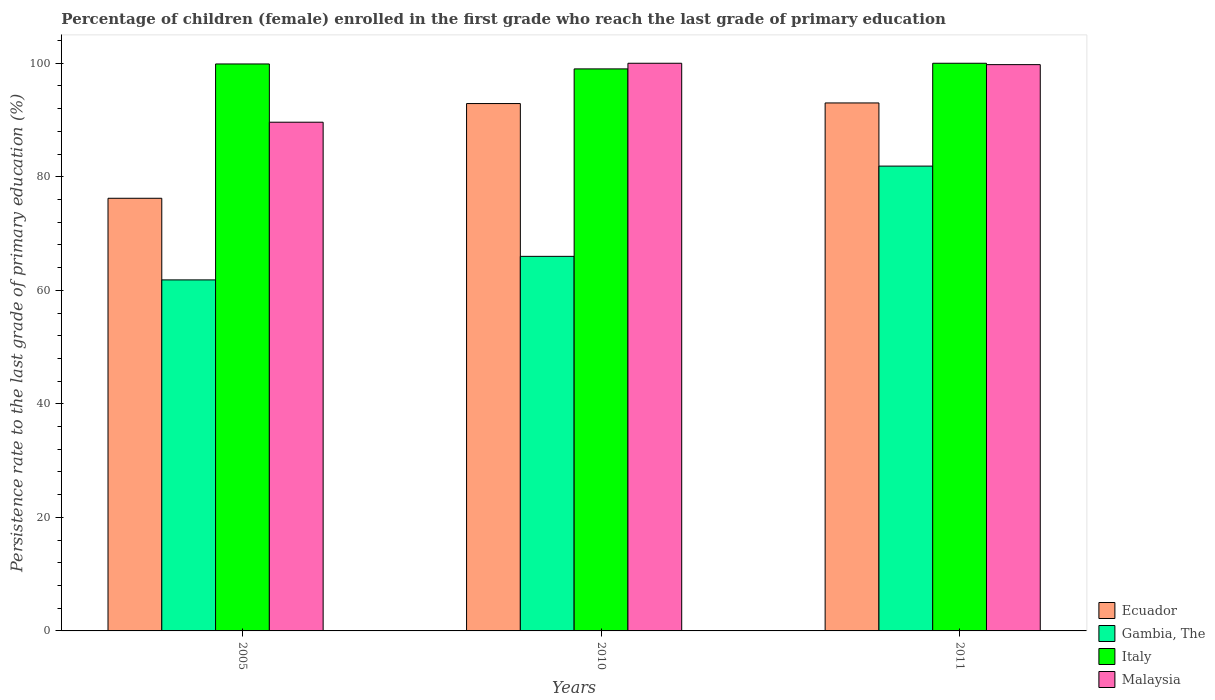How many different coloured bars are there?
Ensure brevity in your answer.  4. How many groups of bars are there?
Provide a succinct answer. 3. Are the number of bars per tick equal to the number of legend labels?
Make the answer very short. Yes. How many bars are there on the 1st tick from the left?
Keep it short and to the point. 4. How many bars are there on the 3rd tick from the right?
Your answer should be compact. 4. In how many cases, is the number of bars for a given year not equal to the number of legend labels?
Offer a terse response. 0. What is the persistence rate of children in Ecuador in 2011?
Ensure brevity in your answer.  93.01. Across all years, what is the maximum persistence rate of children in Ecuador?
Provide a succinct answer. 93.01. Across all years, what is the minimum persistence rate of children in Malaysia?
Keep it short and to the point. 89.61. In which year was the persistence rate of children in Gambia, The minimum?
Offer a terse response. 2005. What is the total persistence rate of children in Ecuador in the graph?
Provide a short and direct response. 262.13. What is the difference between the persistence rate of children in Malaysia in 2005 and that in 2011?
Ensure brevity in your answer.  -10.14. What is the difference between the persistence rate of children in Malaysia in 2011 and the persistence rate of children in Italy in 2005?
Ensure brevity in your answer.  -0.12. What is the average persistence rate of children in Malaysia per year?
Offer a terse response. 96.46. In the year 2005, what is the difference between the persistence rate of children in Ecuador and persistence rate of children in Italy?
Ensure brevity in your answer.  -23.66. In how many years, is the persistence rate of children in Malaysia greater than 36 %?
Provide a succinct answer. 3. What is the ratio of the persistence rate of children in Ecuador in 2010 to that in 2011?
Provide a succinct answer. 1. What is the difference between the highest and the second highest persistence rate of children in Italy?
Your response must be concise. 0.12. What is the difference between the highest and the lowest persistence rate of children in Ecuador?
Your answer should be compact. 16.79. Is the sum of the persistence rate of children in Malaysia in 2005 and 2011 greater than the maximum persistence rate of children in Italy across all years?
Your answer should be very brief. Yes. Is it the case that in every year, the sum of the persistence rate of children in Gambia, The and persistence rate of children in Malaysia is greater than the sum of persistence rate of children in Italy and persistence rate of children in Ecuador?
Offer a terse response. No. What does the 1st bar from the left in 2011 represents?
Offer a terse response. Ecuador. What does the 1st bar from the right in 2005 represents?
Offer a very short reply. Malaysia. How many bars are there?
Keep it short and to the point. 12. Are all the bars in the graph horizontal?
Give a very brief answer. No. Are the values on the major ticks of Y-axis written in scientific E-notation?
Offer a terse response. No. Where does the legend appear in the graph?
Ensure brevity in your answer.  Bottom right. How are the legend labels stacked?
Your response must be concise. Vertical. What is the title of the graph?
Provide a short and direct response. Percentage of children (female) enrolled in the first grade who reach the last grade of primary education. What is the label or title of the Y-axis?
Provide a succinct answer. Persistence rate to the last grade of primary education (%). What is the Persistence rate to the last grade of primary education (%) of Ecuador in 2005?
Your answer should be very brief. 76.22. What is the Persistence rate to the last grade of primary education (%) in Gambia, The in 2005?
Give a very brief answer. 61.84. What is the Persistence rate to the last grade of primary education (%) of Italy in 2005?
Provide a succinct answer. 99.88. What is the Persistence rate to the last grade of primary education (%) in Malaysia in 2005?
Ensure brevity in your answer.  89.61. What is the Persistence rate to the last grade of primary education (%) of Ecuador in 2010?
Keep it short and to the point. 92.9. What is the Persistence rate to the last grade of primary education (%) of Gambia, The in 2010?
Ensure brevity in your answer.  65.99. What is the Persistence rate to the last grade of primary education (%) of Italy in 2010?
Keep it short and to the point. 99.01. What is the Persistence rate to the last grade of primary education (%) in Ecuador in 2011?
Provide a succinct answer. 93.01. What is the Persistence rate to the last grade of primary education (%) of Gambia, The in 2011?
Keep it short and to the point. 81.88. What is the Persistence rate to the last grade of primary education (%) of Malaysia in 2011?
Provide a succinct answer. 99.76. Across all years, what is the maximum Persistence rate to the last grade of primary education (%) in Ecuador?
Your answer should be compact. 93.01. Across all years, what is the maximum Persistence rate to the last grade of primary education (%) in Gambia, The?
Offer a terse response. 81.88. Across all years, what is the maximum Persistence rate to the last grade of primary education (%) in Italy?
Give a very brief answer. 100. Across all years, what is the maximum Persistence rate to the last grade of primary education (%) of Malaysia?
Provide a succinct answer. 100. Across all years, what is the minimum Persistence rate to the last grade of primary education (%) of Ecuador?
Give a very brief answer. 76.22. Across all years, what is the minimum Persistence rate to the last grade of primary education (%) in Gambia, The?
Your response must be concise. 61.84. Across all years, what is the minimum Persistence rate to the last grade of primary education (%) of Italy?
Your answer should be compact. 99.01. Across all years, what is the minimum Persistence rate to the last grade of primary education (%) of Malaysia?
Keep it short and to the point. 89.61. What is the total Persistence rate to the last grade of primary education (%) of Ecuador in the graph?
Keep it short and to the point. 262.13. What is the total Persistence rate to the last grade of primary education (%) in Gambia, The in the graph?
Keep it short and to the point. 209.71. What is the total Persistence rate to the last grade of primary education (%) of Italy in the graph?
Keep it short and to the point. 298.88. What is the total Persistence rate to the last grade of primary education (%) in Malaysia in the graph?
Offer a very short reply. 289.37. What is the difference between the Persistence rate to the last grade of primary education (%) of Ecuador in 2005 and that in 2010?
Your answer should be very brief. -16.69. What is the difference between the Persistence rate to the last grade of primary education (%) of Gambia, The in 2005 and that in 2010?
Your answer should be compact. -4.15. What is the difference between the Persistence rate to the last grade of primary education (%) in Italy in 2005 and that in 2010?
Your answer should be compact. 0.87. What is the difference between the Persistence rate to the last grade of primary education (%) in Malaysia in 2005 and that in 2010?
Your answer should be very brief. -10.39. What is the difference between the Persistence rate to the last grade of primary education (%) in Ecuador in 2005 and that in 2011?
Offer a very short reply. -16.79. What is the difference between the Persistence rate to the last grade of primary education (%) in Gambia, The in 2005 and that in 2011?
Offer a terse response. -20.04. What is the difference between the Persistence rate to the last grade of primary education (%) in Italy in 2005 and that in 2011?
Make the answer very short. -0.12. What is the difference between the Persistence rate to the last grade of primary education (%) in Malaysia in 2005 and that in 2011?
Ensure brevity in your answer.  -10.14. What is the difference between the Persistence rate to the last grade of primary education (%) in Ecuador in 2010 and that in 2011?
Ensure brevity in your answer.  -0.1. What is the difference between the Persistence rate to the last grade of primary education (%) in Gambia, The in 2010 and that in 2011?
Keep it short and to the point. -15.9. What is the difference between the Persistence rate to the last grade of primary education (%) of Italy in 2010 and that in 2011?
Your answer should be compact. -0.99. What is the difference between the Persistence rate to the last grade of primary education (%) in Malaysia in 2010 and that in 2011?
Offer a terse response. 0.24. What is the difference between the Persistence rate to the last grade of primary education (%) of Ecuador in 2005 and the Persistence rate to the last grade of primary education (%) of Gambia, The in 2010?
Provide a succinct answer. 10.23. What is the difference between the Persistence rate to the last grade of primary education (%) in Ecuador in 2005 and the Persistence rate to the last grade of primary education (%) in Italy in 2010?
Ensure brevity in your answer.  -22.79. What is the difference between the Persistence rate to the last grade of primary education (%) of Ecuador in 2005 and the Persistence rate to the last grade of primary education (%) of Malaysia in 2010?
Ensure brevity in your answer.  -23.78. What is the difference between the Persistence rate to the last grade of primary education (%) of Gambia, The in 2005 and the Persistence rate to the last grade of primary education (%) of Italy in 2010?
Offer a very short reply. -37.17. What is the difference between the Persistence rate to the last grade of primary education (%) in Gambia, The in 2005 and the Persistence rate to the last grade of primary education (%) in Malaysia in 2010?
Keep it short and to the point. -38.16. What is the difference between the Persistence rate to the last grade of primary education (%) of Italy in 2005 and the Persistence rate to the last grade of primary education (%) of Malaysia in 2010?
Make the answer very short. -0.12. What is the difference between the Persistence rate to the last grade of primary education (%) of Ecuador in 2005 and the Persistence rate to the last grade of primary education (%) of Gambia, The in 2011?
Ensure brevity in your answer.  -5.67. What is the difference between the Persistence rate to the last grade of primary education (%) of Ecuador in 2005 and the Persistence rate to the last grade of primary education (%) of Italy in 2011?
Provide a short and direct response. -23.78. What is the difference between the Persistence rate to the last grade of primary education (%) in Ecuador in 2005 and the Persistence rate to the last grade of primary education (%) in Malaysia in 2011?
Your answer should be compact. -23.54. What is the difference between the Persistence rate to the last grade of primary education (%) in Gambia, The in 2005 and the Persistence rate to the last grade of primary education (%) in Italy in 2011?
Offer a very short reply. -38.16. What is the difference between the Persistence rate to the last grade of primary education (%) in Gambia, The in 2005 and the Persistence rate to the last grade of primary education (%) in Malaysia in 2011?
Ensure brevity in your answer.  -37.92. What is the difference between the Persistence rate to the last grade of primary education (%) in Italy in 2005 and the Persistence rate to the last grade of primary education (%) in Malaysia in 2011?
Your response must be concise. 0.12. What is the difference between the Persistence rate to the last grade of primary education (%) in Ecuador in 2010 and the Persistence rate to the last grade of primary education (%) in Gambia, The in 2011?
Your response must be concise. 11.02. What is the difference between the Persistence rate to the last grade of primary education (%) in Ecuador in 2010 and the Persistence rate to the last grade of primary education (%) in Italy in 2011?
Give a very brief answer. -7.1. What is the difference between the Persistence rate to the last grade of primary education (%) of Ecuador in 2010 and the Persistence rate to the last grade of primary education (%) of Malaysia in 2011?
Give a very brief answer. -6.86. What is the difference between the Persistence rate to the last grade of primary education (%) of Gambia, The in 2010 and the Persistence rate to the last grade of primary education (%) of Italy in 2011?
Give a very brief answer. -34.01. What is the difference between the Persistence rate to the last grade of primary education (%) in Gambia, The in 2010 and the Persistence rate to the last grade of primary education (%) in Malaysia in 2011?
Give a very brief answer. -33.77. What is the difference between the Persistence rate to the last grade of primary education (%) in Italy in 2010 and the Persistence rate to the last grade of primary education (%) in Malaysia in 2011?
Make the answer very short. -0.75. What is the average Persistence rate to the last grade of primary education (%) of Ecuador per year?
Keep it short and to the point. 87.38. What is the average Persistence rate to the last grade of primary education (%) in Gambia, The per year?
Give a very brief answer. 69.9. What is the average Persistence rate to the last grade of primary education (%) of Italy per year?
Make the answer very short. 99.63. What is the average Persistence rate to the last grade of primary education (%) in Malaysia per year?
Your answer should be compact. 96.46. In the year 2005, what is the difference between the Persistence rate to the last grade of primary education (%) in Ecuador and Persistence rate to the last grade of primary education (%) in Gambia, The?
Provide a succinct answer. 14.38. In the year 2005, what is the difference between the Persistence rate to the last grade of primary education (%) in Ecuador and Persistence rate to the last grade of primary education (%) in Italy?
Offer a very short reply. -23.66. In the year 2005, what is the difference between the Persistence rate to the last grade of primary education (%) in Ecuador and Persistence rate to the last grade of primary education (%) in Malaysia?
Ensure brevity in your answer.  -13.4. In the year 2005, what is the difference between the Persistence rate to the last grade of primary education (%) in Gambia, The and Persistence rate to the last grade of primary education (%) in Italy?
Your answer should be very brief. -38.04. In the year 2005, what is the difference between the Persistence rate to the last grade of primary education (%) in Gambia, The and Persistence rate to the last grade of primary education (%) in Malaysia?
Your answer should be compact. -27.78. In the year 2005, what is the difference between the Persistence rate to the last grade of primary education (%) in Italy and Persistence rate to the last grade of primary education (%) in Malaysia?
Your response must be concise. 10.26. In the year 2010, what is the difference between the Persistence rate to the last grade of primary education (%) in Ecuador and Persistence rate to the last grade of primary education (%) in Gambia, The?
Your answer should be compact. 26.92. In the year 2010, what is the difference between the Persistence rate to the last grade of primary education (%) of Ecuador and Persistence rate to the last grade of primary education (%) of Italy?
Offer a terse response. -6.1. In the year 2010, what is the difference between the Persistence rate to the last grade of primary education (%) of Ecuador and Persistence rate to the last grade of primary education (%) of Malaysia?
Offer a terse response. -7.1. In the year 2010, what is the difference between the Persistence rate to the last grade of primary education (%) of Gambia, The and Persistence rate to the last grade of primary education (%) of Italy?
Offer a very short reply. -33.02. In the year 2010, what is the difference between the Persistence rate to the last grade of primary education (%) in Gambia, The and Persistence rate to the last grade of primary education (%) in Malaysia?
Ensure brevity in your answer.  -34.01. In the year 2010, what is the difference between the Persistence rate to the last grade of primary education (%) in Italy and Persistence rate to the last grade of primary education (%) in Malaysia?
Give a very brief answer. -0.99. In the year 2011, what is the difference between the Persistence rate to the last grade of primary education (%) of Ecuador and Persistence rate to the last grade of primary education (%) of Gambia, The?
Ensure brevity in your answer.  11.12. In the year 2011, what is the difference between the Persistence rate to the last grade of primary education (%) in Ecuador and Persistence rate to the last grade of primary education (%) in Italy?
Offer a terse response. -6.99. In the year 2011, what is the difference between the Persistence rate to the last grade of primary education (%) of Ecuador and Persistence rate to the last grade of primary education (%) of Malaysia?
Provide a short and direct response. -6.75. In the year 2011, what is the difference between the Persistence rate to the last grade of primary education (%) of Gambia, The and Persistence rate to the last grade of primary education (%) of Italy?
Provide a succinct answer. -18.12. In the year 2011, what is the difference between the Persistence rate to the last grade of primary education (%) in Gambia, The and Persistence rate to the last grade of primary education (%) in Malaysia?
Your response must be concise. -17.87. In the year 2011, what is the difference between the Persistence rate to the last grade of primary education (%) of Italy and Persistence rate to the last grade of primary education (%) of Malaysia?
Your answer should be compact. 0.24. What is the ratio of the Persistence rate to the last grade of primary education (%) in Ecuador in 2005 to that in 2010?
Your answer should be very brief. 0.82. What is the ratio of the Persistence rate to the last grade of primary education (%) of Gambia, The in 2005 to that in 2010?
Give a very brief answer. 0.94. What is the ratio of the Persistence rate to the last grade of primary education (%) in Italy in 2005 to that in 2010?
Keep it short and to the point. 1.01. What is the ratio of the Persistence rate to the last grade of primary education (%) in Malaysia in 2005 to that in 2010?
Keep it short and to the point. 0.9. What is the ratio of the Persistence rate to the last grade of primary education (%) in Ecuador in 2005 to that in 2011?
Your answer should be very brief. 0.82. What is the ratio of the Persistence rate to the last grade of primary education (%) of Gambia, The in 2005 to that in 2011?
Offer a very short reply. 0.76. What is the ratio of the Persistence rate to the last grade of primary education (%) in Malaysia in 2005 to that in 2011?
Offer a terse response. 0.9. What is the ratio of the Persistence rate to the last grade of primary education (%) of Gambia, The in 2010 to that in 2011?
Provide a short and direct response. 0.81. What is the ratio of the Persistence rate to the last grade of primary education (%) of Malaysia in 2010 to that in 2011?
Ensure brevity in your answer.  1. What is the difference between the highest and the second highest Persistence rate to the last grade of primary education (%) of Ecuador?
Provide a succinct answer. 0.1. What is the difference between the highest and the second highest Persistence rate to the last grade of primary education (%) in Gambia, The?
Provide a short and direct response. 15.9. What is the difference between the highest and the second highest Persistence rate to the last grade of primary education (%) of Italy?
Offer a very short reply. 0.12. What is the difference between the highest and the second highest Persistence rate to the last grade of primary education (%) in Malaysia?
Offer a terse response. 0.24. What is the difference between the highest and the lowest Persistence rate to the last grade of primary education (%) of Ecuador?
Keep it short and to the point. 16.79. What is the difference between the highest and the lowest Persistence rate to the last grade of primary education (%) in Gambia, The?
Provide a succinct answer. 20.04. What is the difference between the highest and the lowest Persistence rate to the last grade of primary education (%) in Italy?
Offer a terse response. 0.99. What is the difference between the highest and the lowest Persistence rate to the last grade of primary education (%) of Malaysia?
Give a very brief answer. 10.39. 